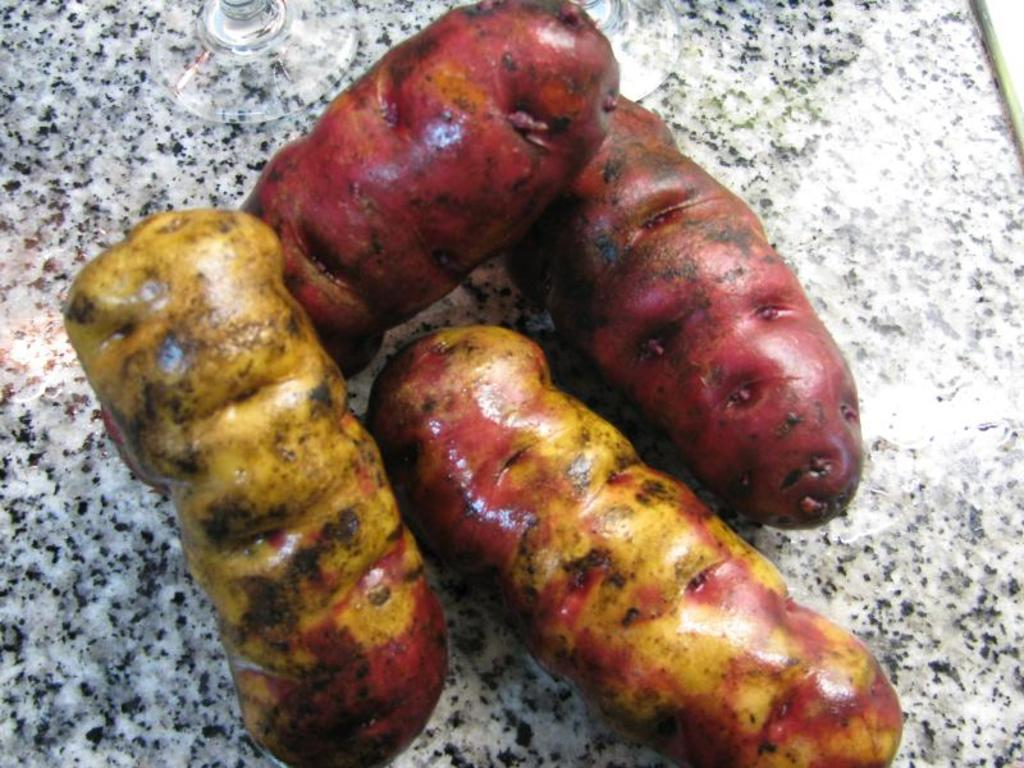What type of items can be seen in the image? The image contains food. What type of farmer is depicted in the image? There is no farmer present in the image; it only contains food. What type of jar can be seen holding the food in the image? There is no jar present in the image; it only contains food. 